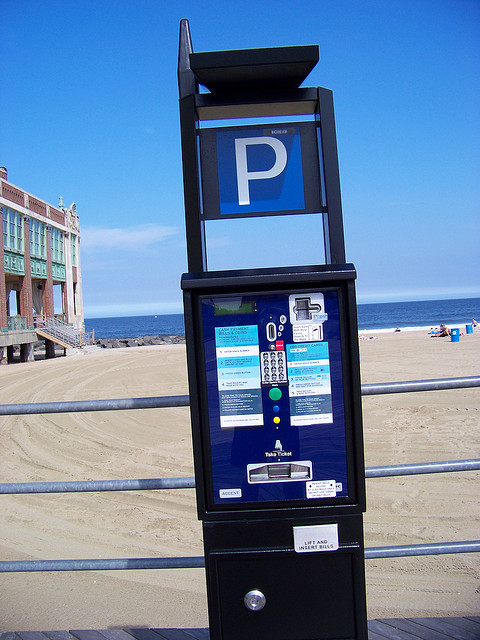Identify the text displayed in this image. P AND LINE 